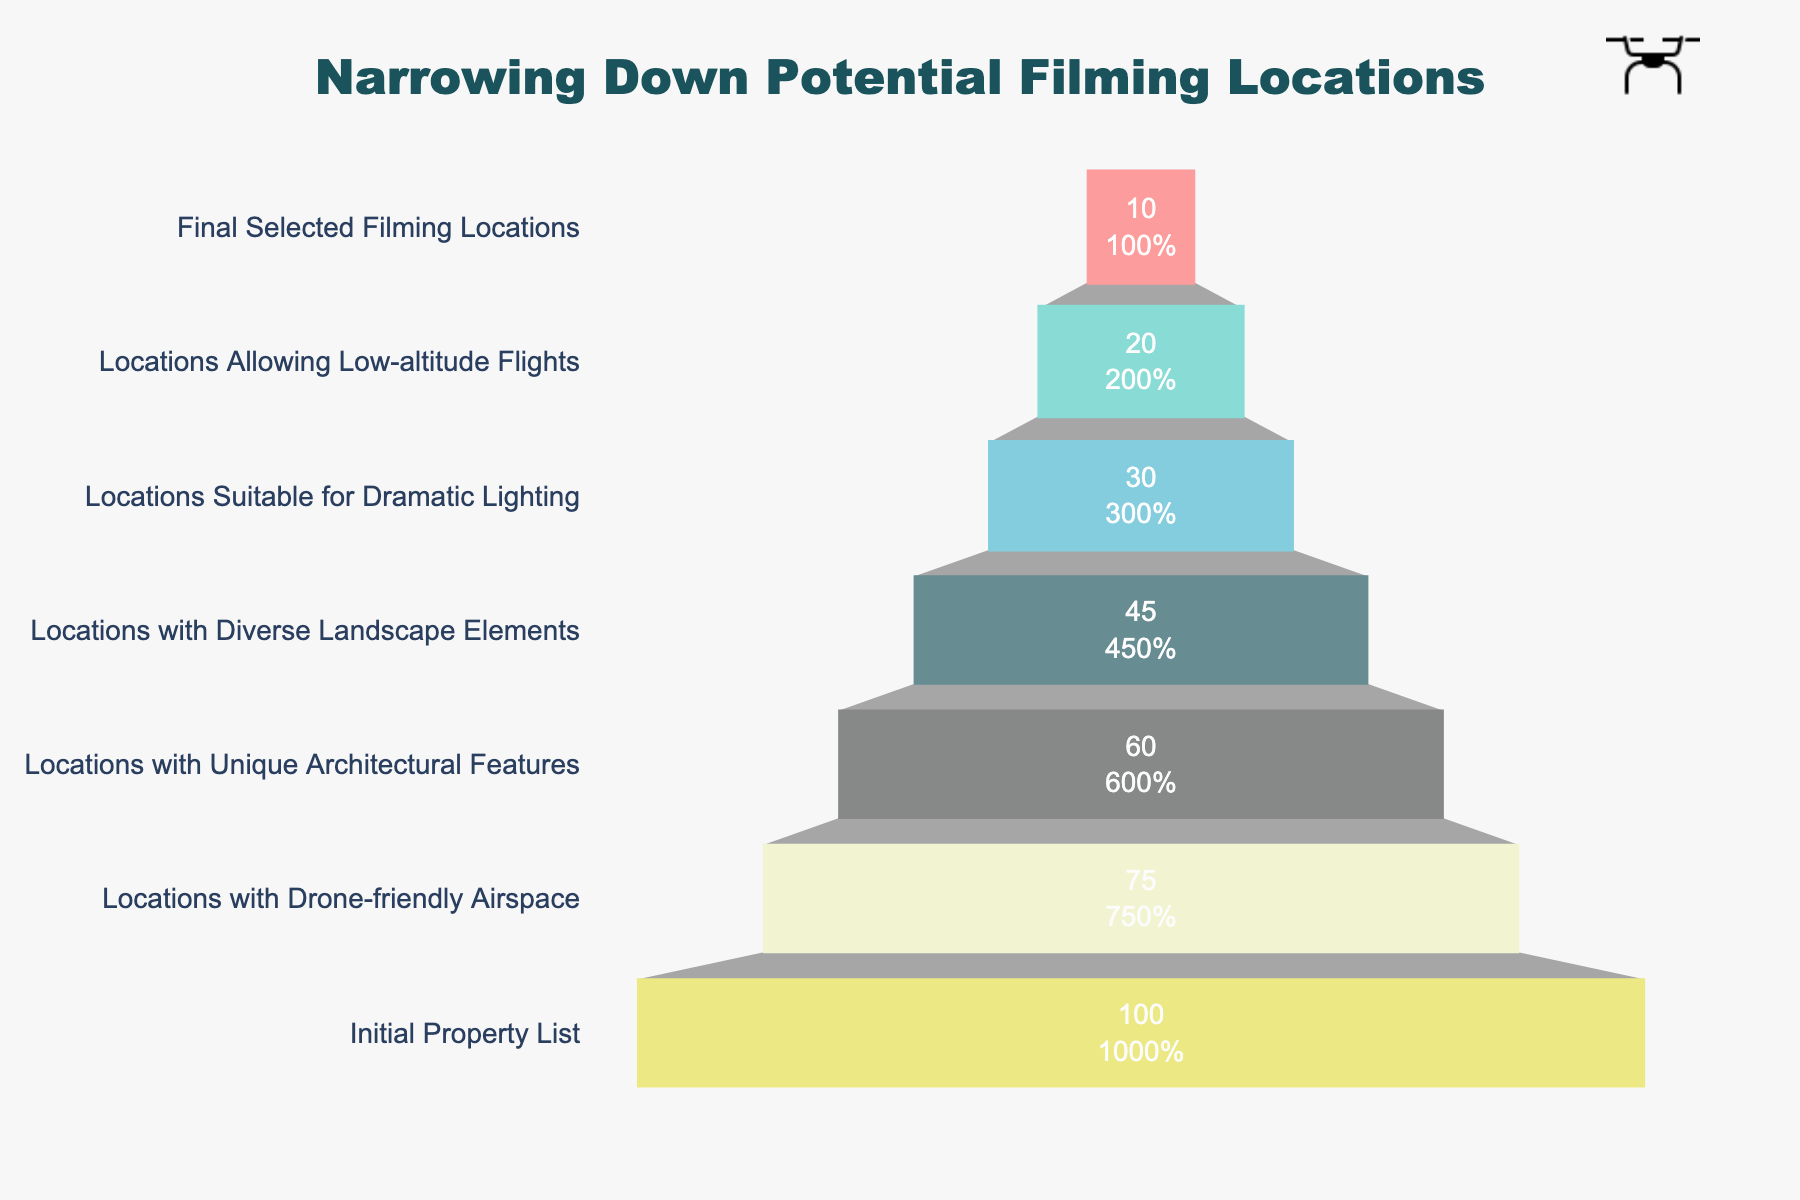What is the title of the funnel chart? The title is typically displayed at the top of the chart. In this case, the title is clearly mentioned in the chart settings.
Answer: Narrowing Down Potential Filming Locations How many stages are there in narrowing down the filming locations? By counting the bars or stages in the funnel, you can see there are seven distinct stages listed.
Answer: 7 What's the number of locations that have drone-friendly airspace? Look at the stage labeled "Locations with Drone-friendly Airspace" in the funnel chart, where the number of locations is directly mentioned.
Answer: 75 How many locations were eliminated between the "Locations with Unique Architectural Features" stage and the "Locations Allowing Low-altitude Flights" stage? Subtract the number of locations at the "Locations Allowing Low-altitude Flights" stage (20) from the "Locations with Unique Architectural Features" stage (60): 60 - 20 = 40
Answer: 40 What percentage of the initial property list is retained in the final selected filming locations? The final selected locations are 10, and the initial list had 100 locations. The percentage is calculated as (10 / 100) * 100 = 10%.
Answer: 10% Which stage had the largest drop in the number of locations compared to the previous stage? Calculate the difference in the number of locations between each consecutive stage, and find the stage with the maximum drop:
1. 100 - 75 = 25
2. 75 - 60 = 15
3. 60 - 45 = 15
4. 45 - 30 = 15
5. 30 - 20 = 10
6. 20 - 10 = 10
The largest drop is from the "Initial Property List" to "Locations with Drone-friendly Airspace" stage.
Answer: Initial Property List to Locations with Drone-friendly Airspace Between which two stages was the number of locations reduced by exactly half? To find a 50% reduction, divide the number of locations at each stage by 2 and compare with the subsequent stage: 
1. 100 / 2 = 50 (None)
2. 75 / 2 = 37.5 (None)
3. 60 / 2 = 30 (Matches "Locations Suitable for Dramatic Lighting")
4. 45 / 2 = 22.5 (None)
5. 30 / 2 = 15 (None)
6. 20 / 2 = 10 (Matches "Final Selected Filming Locations")
The stage transitions that fit are from "Locations with Unique Architectural Features" to "Locations Suitable for Dramatic Lighting," and from "Locations Allowing Low-altitude Flights" to "Final Selected Filming Locations."
Answer: Locations with Unique Architectural Features to Locations Suitable for Dramatic Lighting and Locations Allowing Low-altitude Flights to Final Selected Filming Locations Which stage follows "Locations Suitable for Dramatic Lighting"? The sequence of the stages indicates that the stage that comes immediately after "Locations Suitable for Dramatic Lighting" is "Locations Allowing Low-altitude Flights."
Answer: Locations Allowing Low-altitude Flights 